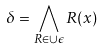Convert formula to latex. <formula><loc_0><loc_0><loc_500><loc_500>\delta = \bigwedge _ { R \in \cup \epsilon } R ( x )</formula> 